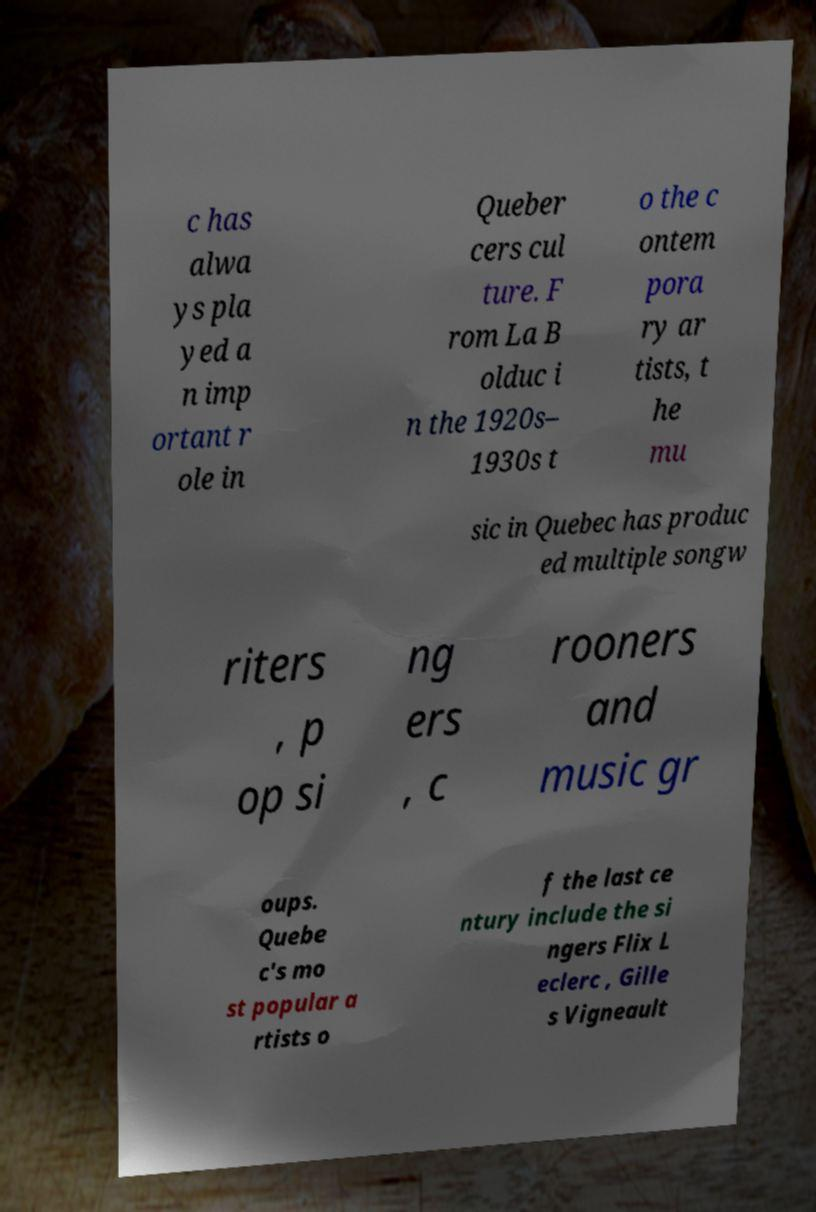What messages or text are displayed in this image? I need them in a readable, typed format. c has alwa ys pla yed a n imp ortant r ole in Queber cers cul ture. F rom La B olduc i n the 1920s– 1930s t o the c ontem pora ry ar tists, t he mu sic in Quebec has produc ed multiple songw riters , p op si ng ers , c rooners and music gr oups. Quebe c's mo st popular a rtists o f the last ce ntury include the si ngers Flix L eclerc , Gille s Vigneault 